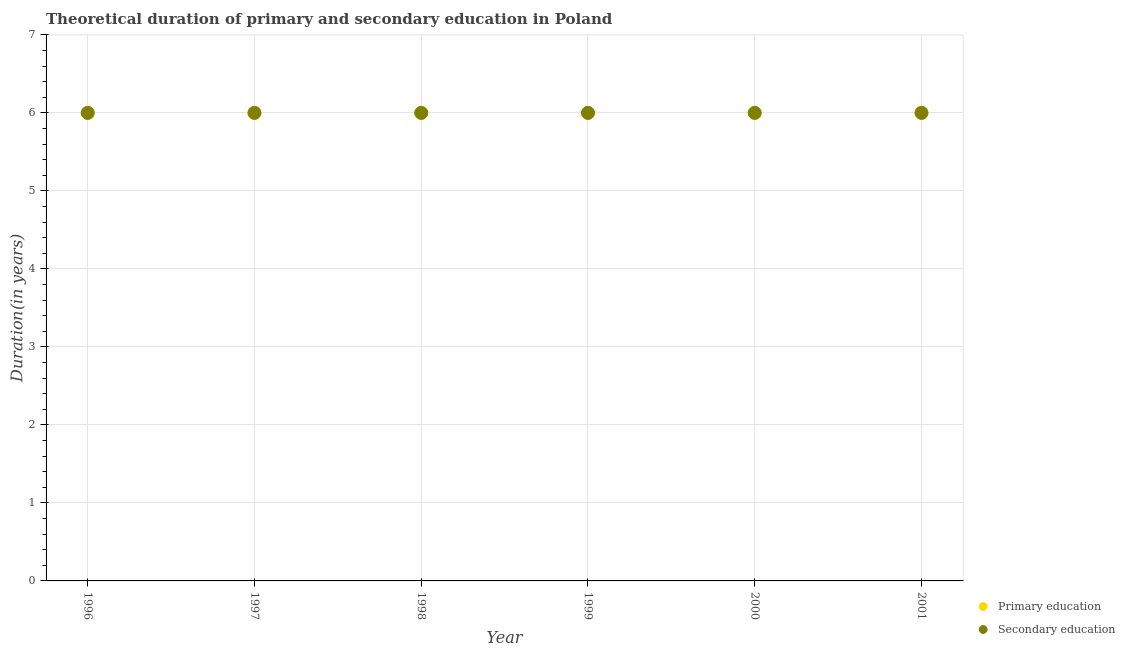How many different coloured dotlines are there?
Give a very brief answer. 2. Across all years, what is the minimum duration of primary education?
Offer a very short reply. 6. What is the total duration of secondary education in the graph?
Offer a very short reply. 36. What is the difference between the duration of secondary education in 2001 and the duration of primary education in 1998?
Your answer should be very brief. 0. What is the average duration of secondary education per year?
Your answer should be compact. 6. In the year 1996, what is the difference between the duration of primary education and duration of secondary education?
Offer a terse response. 0. What is the ratio of the duration of primary education in 1997 to that in 2001?
Your answer should be compact. 1. Is the duration of secondary education in 1998 less than that in 2001?
Give a very brief answer. No. Is the difference between the duration of primary education in 1997 and 1998 greater than the difference between the duration of secondary education in 1997 and 1998?
Provide a succinct answer. No. In how many years, is the duration of primary education greater than the average duration of primary education taken over all years?
Offer a terse response. 0. Is the sum of the duration of primary education in 1997 and 1999 greater than the maximum duration of secondary education across all years?
Ensure brevity in your answer.  Yes. Does the duration of secondary education monotonically increase over the years?
Your answer should be compact. No. How many dotlines are there?
Offer a very short reply. 2. What is the difference between two consecutive major ticks on the Y-axis?
Ensure brevity in your answer.  1. Does the graph contain any zero values?
Ensure brevity in your answer.  No. How are the legend labels stacked?
Offer a very short reply. Vertical. What is the title of the graph?
Provide a succinct answer. Theoretical duration of primary and secondary education in Poland. Does "Arms exports" appear as one of the legend labels in the graph?
Provide a succinct answer. No. What is the label or title of the X-axis?
Offer a very short reply. Year. What is the label or title of the Y-axis?
Keep it short and to the point. Duration(in years). What is the Duration(in years) in Primary education in 1996?
Offer a terse response. 6. What is the Duration(in years) in Primary education in 1997?
Your answer should be compact. 6. What is the Duration(in years) in Secondary education in 1997?
Your answer should be compact. 6. What is the Duration(in years) of Secondary education in 1998?
Provide a succinct answer. 6. What is the Duration(in years) in Secondary education in 1999?
Give a very brief answer. 6. What is the Duration(in years) of Primary education in 2000?
Your answer should be very brief. 6. What is the Duration(in years) in Primary education in 2001?
Keep it short and to the point. 6. Across all years, what is the maximum Duration(in years) in Secondary education?
Provide a short and direct response. 6. Across all years, what is the minimum Duration(in years) in Primary education?
Offer a terse response. 6. What is the difference between the Duration(in years) in Primary education in 1996 and that in 1998?
Your response must be concise. 0. What is the difference between the Duration(in years) of Primary education in 1996 and that in 1999?
Provide a short and direct response. 0. What is the difference between the Duration(in years) of Secondary education in 1996 and that in 1999?
Provide a succinct answer. 0. What is the difference between the Duration(in years) in Secondary education in 1996 and that in 2000?
Offer a terse response. 0. What is the difference between the Duration(in years) in Secondary education in 1996 and that in 2001?
Provide a short and direct response. 0. What is the difference between the Duration(in years) of Secondary education in 1997 and that in 1998?
Your answer should be very brief. 0. What is the difference between the Duration(in years) of Primary education in 1997 and that in 1999?
Make the answer very short. 0. What is the difference between the Duration(in years) in Primary education in 1997 and that in 2001?
Offer a very short reply. 0. What is the difference between the Duration(in years) in Primary education in 1998 and that in 1999?
Make the answer very short. 0. What is the difference between the Duration(in years) of Secondary education in 1998 and that in 1999?
Make the answer very short. 0. What is the difference between the Duration(in years) of Primary education in 1998 and that in 2000?
Your response must be concise. 0. What is the difference between the Duration(in years) in Secondary education in 1998 and that in 2000?
Provide a succinct answer. 0. What is the difference between the Duration(in years) in Primary education in 1998 and that in 2001?
Keep it short and to the point. 0. What is the difference between the Duration(in years) in Secondary education in 1998 and that in 2001?
Offer a very short reply. 0. What is the difference between the Duration(in years) of Secondary education in 1999 and that in 2001?
Make the answer very short. 0. What is the difference between the Duration(in years) in Secondary education in 2000 and that in 2001?
Offer a very short reply. 0. What is the difference between the Duration(in years) of Primary education in 1996 and the Duration(in years) of Secondary education in 1997?
Offer a terse response. 0. What is the difference between the Duration(in years) in Primary education in 1996 and the Duration(in years) in Secondary education in 1998?
Offer a very short reply. 0. What is the difference between the Duration(in years) of Primary education in 1996 and the Duration(in years) of Secondary education in 1999?
Your answer should be very brief. 0. What is the difference between the Duration(in years) of Primary education in 1996 and the Duration(in years) of Secondary education in 2000?
Offer a terse response. 0. What is the difference between the Duration(in years) of Primary education in 1996 and the Duration(in years) of Secondary education in 2001?
Keep it short and to the point. 0. What is the difference between the Duration(in years) of Primary education in 1997 and the Duration(in years) of Secondary education in 1999?
Make the answer very short. 0. What is the difference between the Duration(in years) in Primary education in 1997 and the Duration(in years) in Secondary education in 2000?
Provide a short and direct response. 0. What is the difference between the Duration(in years) in Primary education in 1998 and the Duration(in years) in Secondary education in 2000?
Provide a succinct answer. 0. What is the difference between the Duration(in years) in Primary education in 1999 and the Duration(in years) in Secondary education in 2000?
Ensure brevity in your answer.  0. What is the difference between the Duration(in years) of Primary education in 1999 and the Duration(in years) of Secondary education in 2001?
Keep it short and to the point. 0. What is the average Duration(in years) in Secondary education per year?
Offer a terse response. 6. In the year 1998, what is the difference between the Duration(in years) in Primary education and Duration(in years) in Secondary education?
Ensure brevity in your answer.  0. In the year 2001, what is the difference between the Duration(in years) in Primary education and Duration(in years) in Secondary education?
Offer a very short reply. 0. What is the ratio of the Duration(in years) of Primary education in 1996 to that in 1997?
Give a very brief answer. 1. What is the ratio of the Duration(in years) of Secondary education in 1996 to that in 1997?
Ensure brevity in your answer.  1. What is the ratio of the Duration(in years) of Secondary education in 1996 to that in 1998?
Give a very brief answer. 1. What is the ratio of the Duration(in years) of Primary education in 1996 to that in 2000?
Offer a very short reply. 1. What is the ratio of the Duration(in years) of Secondary education in 1996 to that in 2000?
Your answer should be compact. 1. What is the ratio of the Duration(in years) in Secondary education in 1996 to that in 2001?
Keep it short and to the point. 1. What is the ratio of the Duration(in years) in Primary education in 1997 to that in 2000?
Provide a succinct answer. 1. What is the ratio of the Duration(in years) of Primary education in 1998 to that in 1999?
Your answer should be compact. 1. What is the ratio of the Duration(in years) of Secondary education in 1998 to that in 1999?
Ensure brevity in your answer.  1. What is the ratio of the Duration(in years) in Secondary education in 1998 to that in 2001?
Provide a succinct answer. 1. What is the ratio of the Duration(in years) in Primary education in 1999 to that in 2001?
Your answer should be compact. 1. What is the ratio of the Duration(in years) in Secondary education in 1999 to that in 2001?
Your answer should be compact. 1. What is the difference between the highest and the lowest Duration(in years) of Secondary education?
Ensure brevity in your answer.  0. 